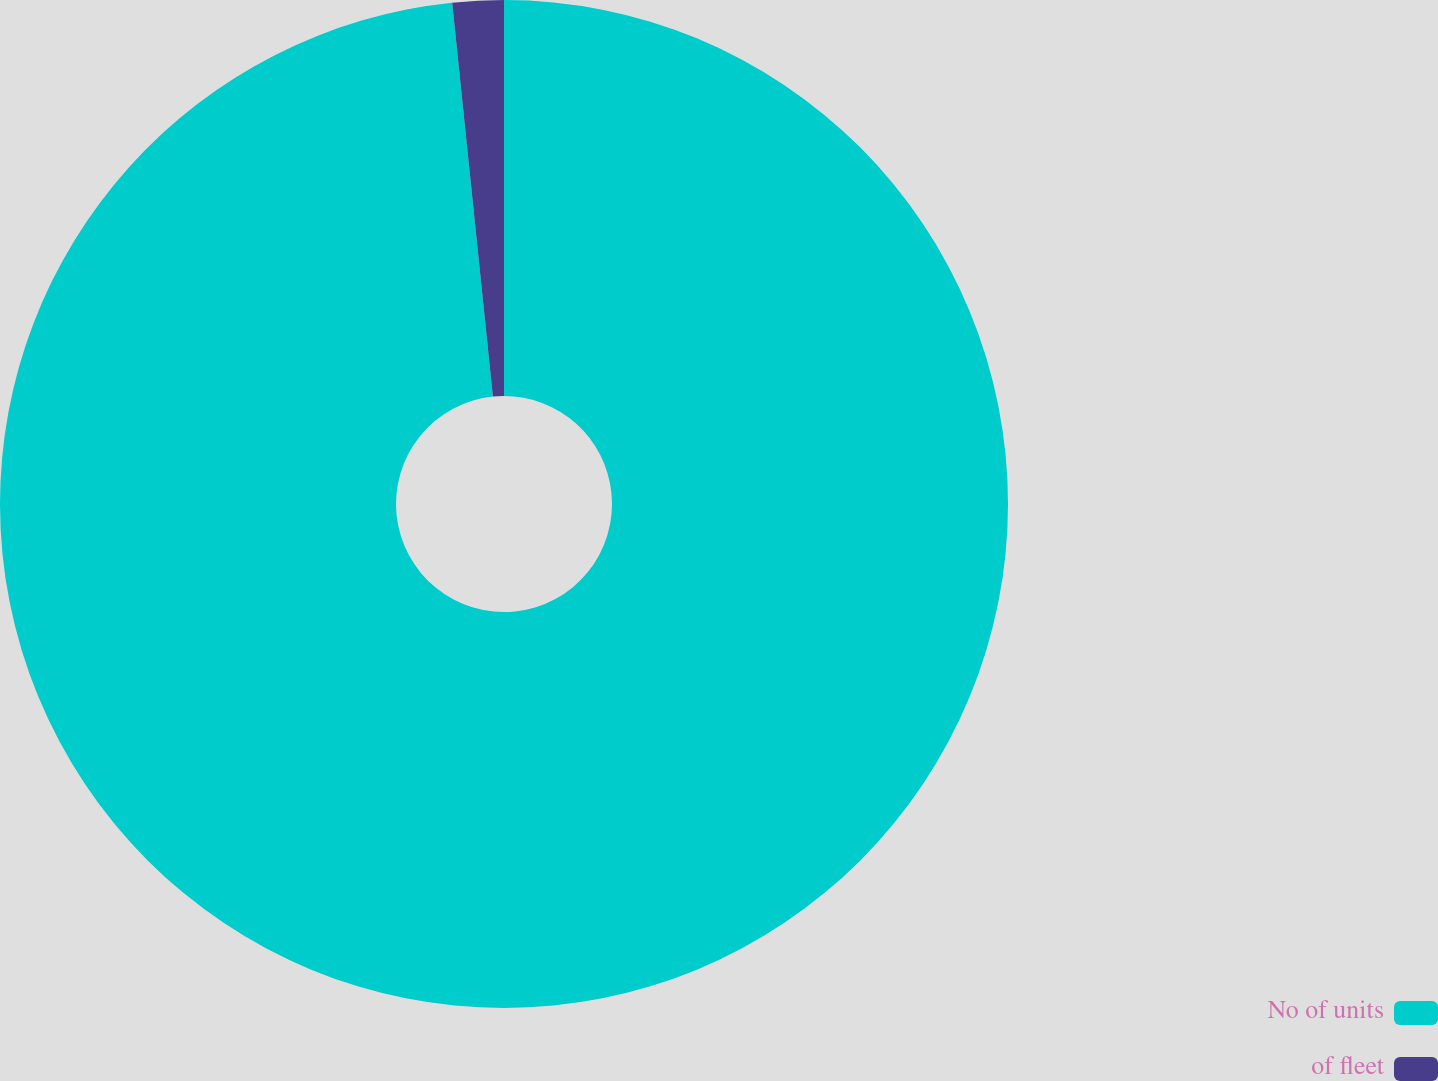Convert chart to OTSL. <chart><loc_0><loc_0><loc_500><loc_500><pie_chart><fcel>No of units<fcel>of fleet<nl><fcel>98.36%<fcel>1.64%<nl></chart> 